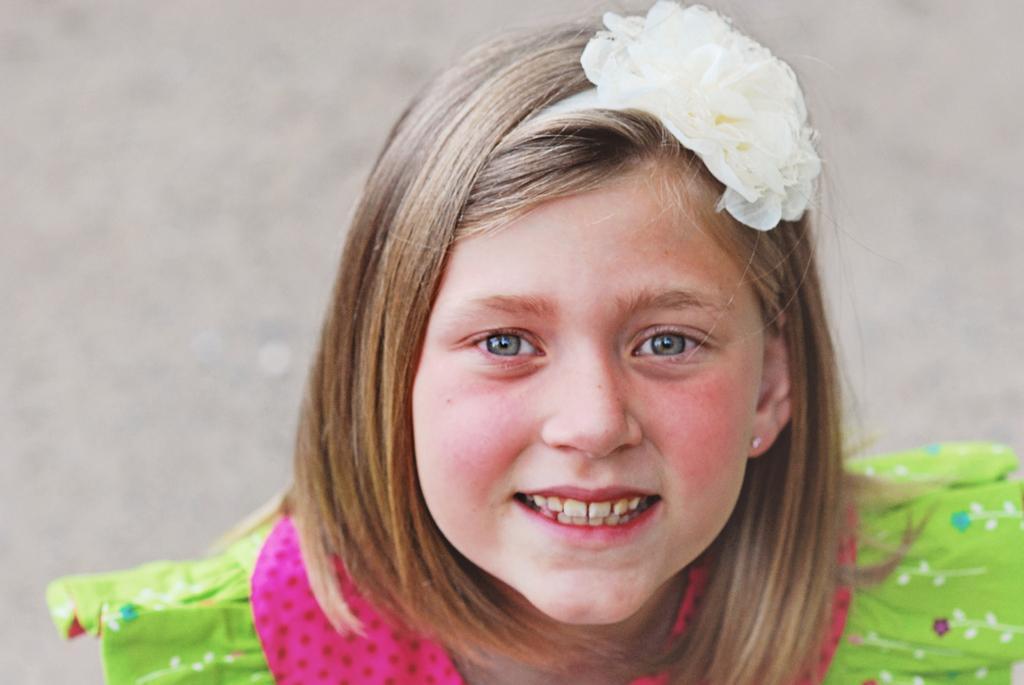Can you describe this image briefly? In the center of the image we can see a girl smiling. She is wearing a green dress. 